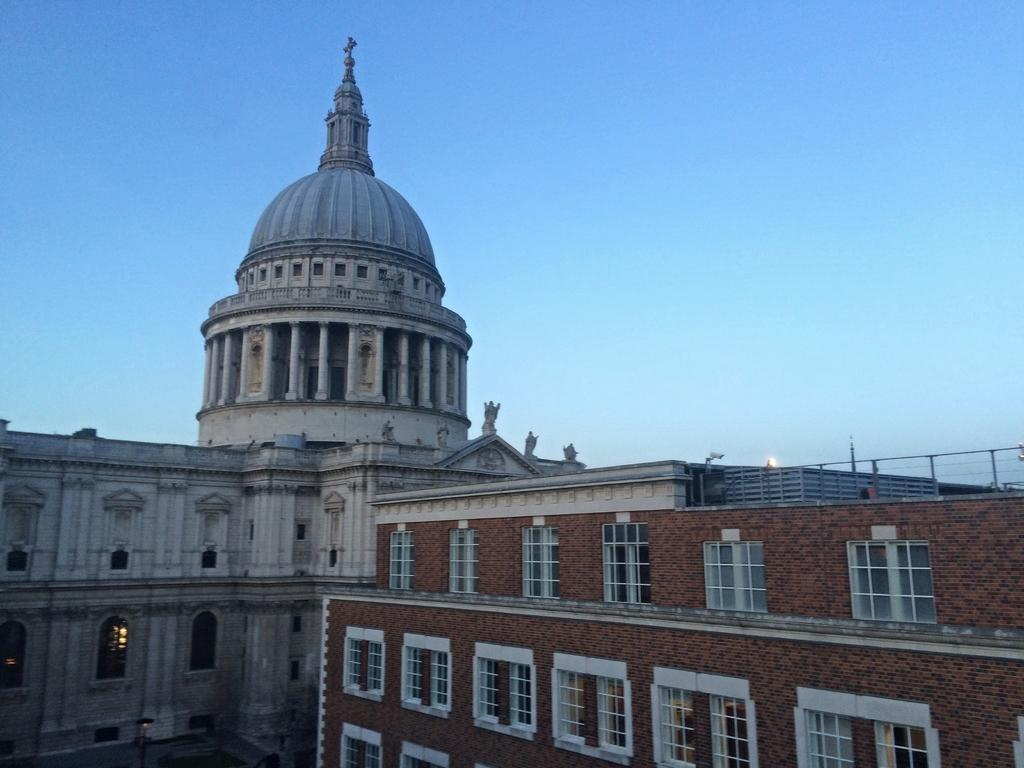What type of structure is in the image? There is a building in the image. What feature can be seen on top of the building? The building has a dome on top. What can be seen in the background of the image? The sky is visible in the background of the image. What type of skin is visible on the building in the image? There is no skin visible on the building in the image; it is a structure made of materials like brick, stone, or concrete. 